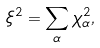Convert formula to latex. <formula><loc_0><loc_0><loc_500><loc_500>\xi ^ { 2 } = \sum _ { \alpha } \chi _ { \alpha } ^ { 2 } ,</formula> 